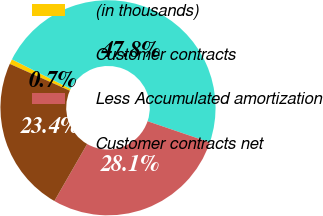Convert chart. <chart><loc_0><loc_0><loc_500><loc_500><pie_chart><fcel>(in thousands)<fcel>Customer contracts<fcel>Less Accumulated amortization<fcel>Customer contracts net<nl><fcel>0.74%<fcel>47.79%<fcel>28.08%<fcel>23.38%<nl></chart> 